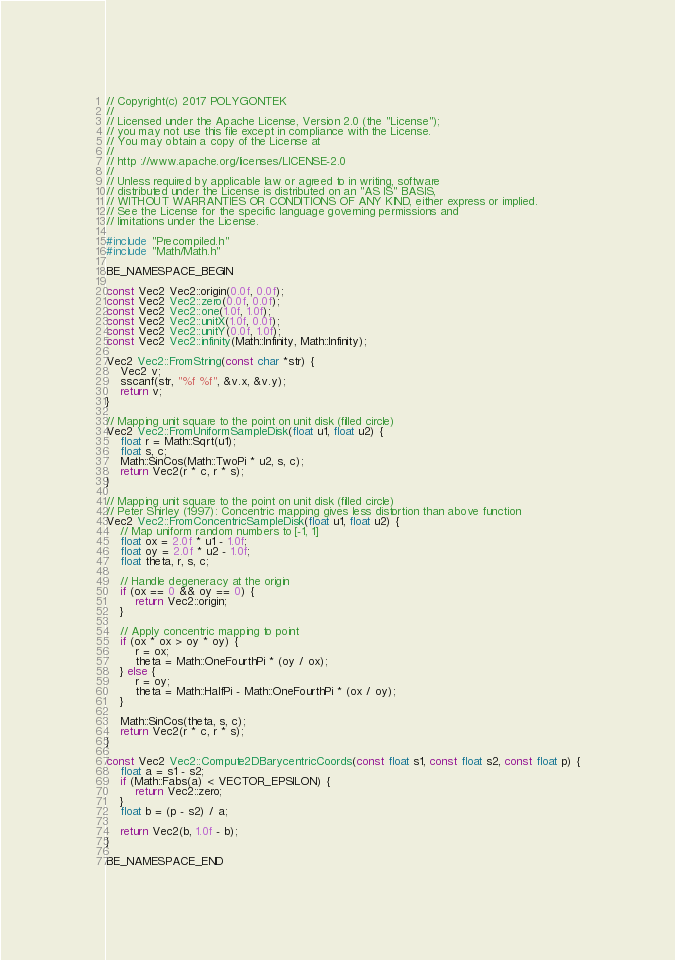Convert code to text. <code><loc_0><loc_0><loc_500><loc_500><_C++_>// Copyright(c) 2017 POLYGONTEK
// 
// Licensed under the Apache License, Version 2.0 (the "License");
// you may not use this file except in compliance with the License.
// You may obtain a copy of the License at
// 
// http ://www.apache.org/licenses/LICENSE-2.0
// 
// Unless required by applicable law or agreed to in writing, software
// distributed under the License is distributed on an "AS IS" BASIS,
// WITHOUT WARRANTIES OR CONDITIONS OF ANY KIND, either express or implied.
// See the License for the specific language governing permissions and
// limitations under the License.

#include "Precompiled.h"
#include "Math/Math.h"

BE_NAMESPACE_BEGIN

const Vec2 Vec2::origin(0.0f, 0.0f);
const Vec2 Vec2::zero(0.0f, 0.0f);
const Vec2 Vec2::one(1.0f, 1.0f);
const Vec2 Vec2::unitX(1.0f, 0.0f);
const Vec2 Vec2::unitY(0.0f, 1.0f);
const Vec2 Vec2::infinity(Math::Infinity, Math::Infinity);

Vec2 Vec2::FromString(const char *str) {
    Vec2 v;
    sscanf(str, "%f %f", &v.x, &v.y);
    return v;
}

// Mapping unit square to the point on unit disk (filled circle)
Vec2 Vec2::FromUniformSampleDisk(float u1, float u2) {
    float r = Math::Sqrt(u1);
    float s, c;
    Math::SinCos(Math::TwoPi * u2, s, c);
    return Vec2(r * c, r * s);
}

// Mapping unit square to the point on unit disk (filled circle) 
// Peter Shirley (1997): Concentric mapping gives less distortion than above function
Vec2 Vec2::FromConcentricSampleDisk(float u1, float u2) {
    // Map uniform random numbers to [-1, 1]
    float ox = 2.0f * u1 - 1.0f;
    float oy = 2.0f * u2 - 1.0f;
    float theta, r, s, c;

    // Handle degeneracy at the origin
    if (ox == 0 && oy == 0) {
        return Vec2::origin;
    }

    // Apply concentric mapping to point
    if (ox * ox > oy * oy) {
        r = ox;
        theta = Math::OneFourthPi * (oy / ox);
    } else {
        r = oy;
        theta = Math::HalfPi - Math::OneFourthPi * (ox / oy);
    }

    Math::SinCos(theta, s, c);
    return Vec2(r * c, r * s);
}

const Vec2 Vec2::Compute2DBarycentricCoords(const float s1, const float s2, const float p) {
    float a = s1 - s2;
    if (Math::Fabs(a) < VECTOR_EPSILON) {
        return Vec2::zero;
    }
    float b = (p - s2) / a;

    return Vec2(b, 1.0f - b);
}

BE_NAMESPACE_END
</code> 